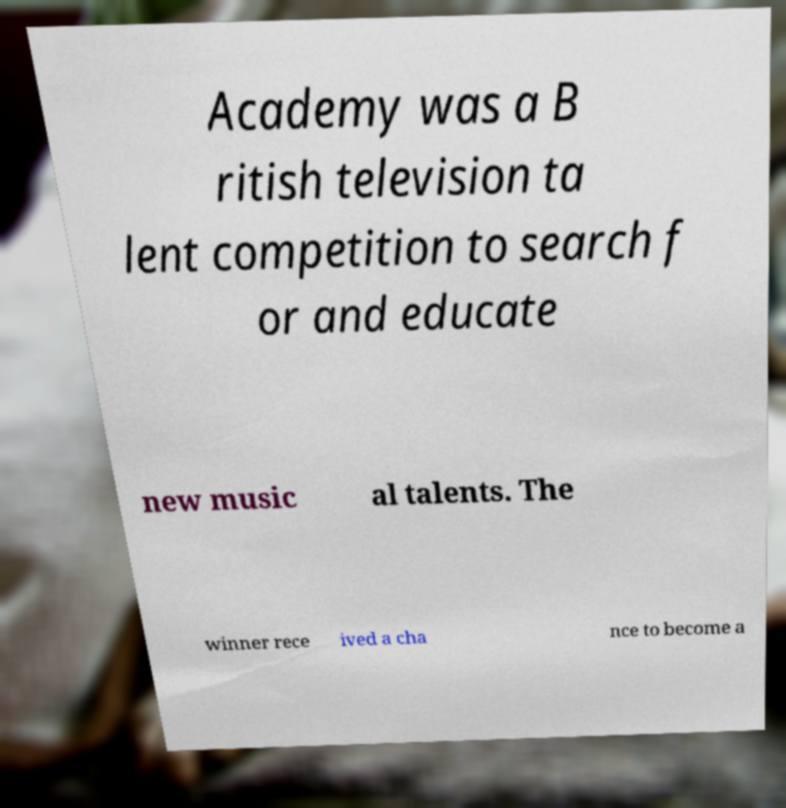Please identify and transcribe the text found in this image. Academy was a B ritish television ta lent competition to search f or and educate new music al talents. The winner rece ived a cha nce to become a 